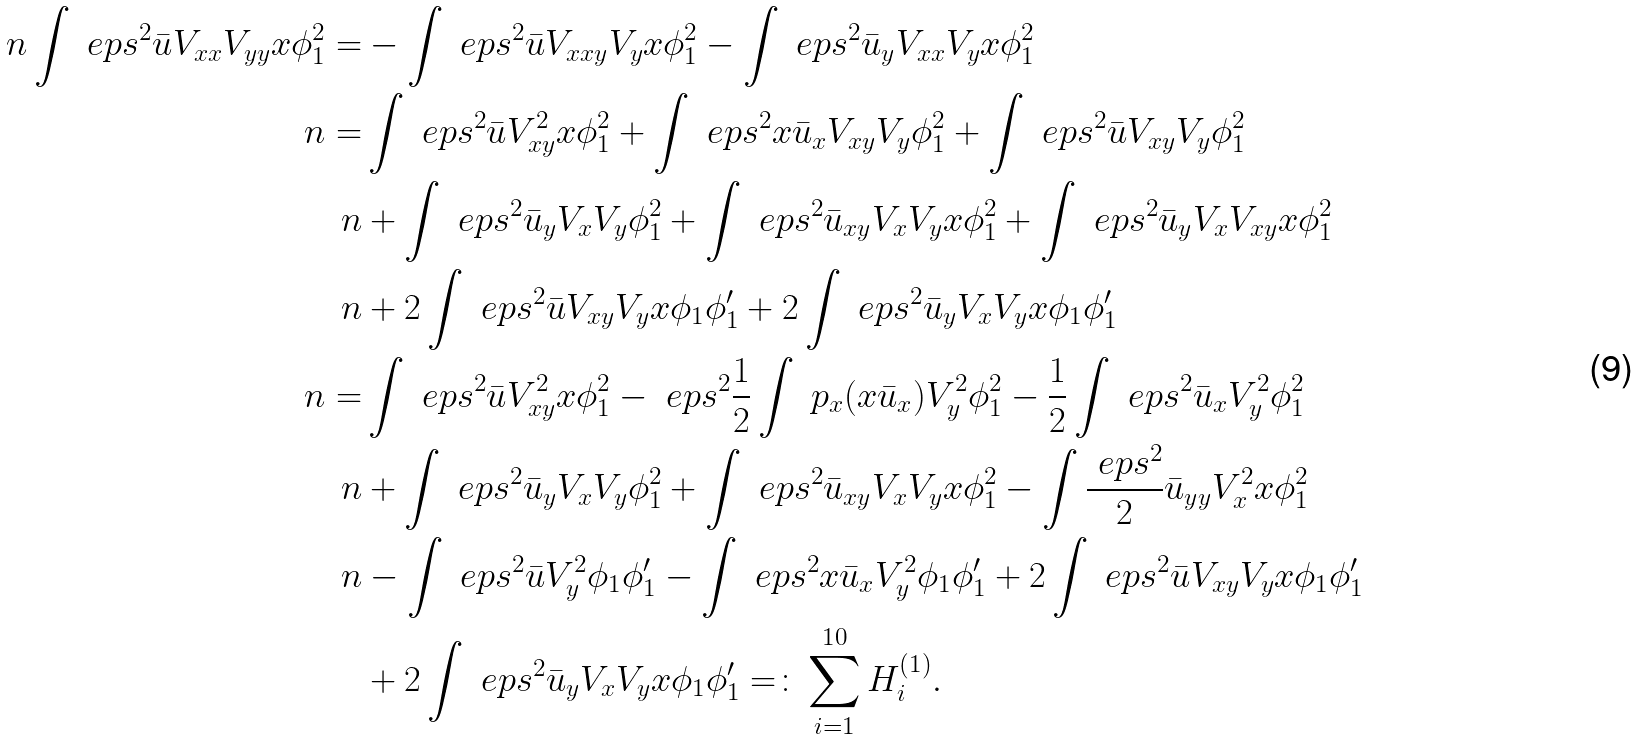<formula> <loc_0><loc_0><loc_500><loc_500>\ n \int \ e p s ^ { 2 } \bar { u } V _ { x x } V _ { y y } x \phi _ { 1 } ^ { 2 } = & - \int \ e p s ^ { 2 } \bar { u } V _ { x x y } V _ { y } x \phi _ { 1 } ^ { 2 } - \int \ e p s ^ { 2 } \bar { u } _ { y } V _ { x x } V _ { y } x \phi _ { 1 } ^ { 2 } \\ \ n = & \int \ e p s ^ { 2 } \bar { u } V _ { x y } ^ { 2 } x \phi _ { 1 } ^ { 2 } + \int \ e p s ^ { 2 } x \bar { u } _ { x } V _ { x y } V _ { y } \phi _ { 1 } ^ { 2 } + \int \ e p s ^ { 2 } \bar { u } V _ { x y } V _ { y } \phi _ { 1 } ^ { 2 } \\ \ n & + \int \ e p s ^ { 2 } \bar { u } _ { y } V _ { x } V _ { y } \phi _ { 1 } ^ { 2 } + \int \ e p s ^ { 2 } \bar { u } _ { x y } V _ { x } V _ { y } x \phi _ { 1 } ^ { 2 } + \int \ e p s ^ { 2 } \bar { u } _ { y } V _ { x } V _ { x y } x \phi _ { 1 } ^ { 2 } \\ \ n & + 2 \int \ e p s ^ { 2 } \bar { u } V _ { x y } V _ { y } x \phi _ { 1 } \phi _ { 1 } ^ { \prime } + 2 \int \ e p s ^ { 2 } \bar { u } _ { y } V _ { x } V _ { y } x \phi _ { 1 } \phi _ { 1 } ^ { \prime } \\ \ n = & \int \ e p s ^ { 2 } \bar { u } V _ { x y } ^ { 2 } x \phi _ { 1 } ^ { 2 } - \ e p s ^ { 2 } \frac { 1 } { 2 } \int \ p _ { x } ( x \bar { u } _ { x } ) V _ { y } ^ { 2 } \phi _ { 1 } ^ { 2 } - \frac { 1 } { 2 } \int \ e p s ^ { 2 } \bar { u } _ { x } V _ { y } ^ { 2 } \phi _ { 1 } ^ { 2 } \\ \ n & + \int \ e p s ^ { 2 } \bar { u } _ { y } V _ { x } V _ { y } \phi _ { 1 } ^ { 2 } + \int \ e p s ^ { 2 } \bar { u } _ { x y } V _ { x } V _ { y } x \phi _ { 1 } ^ { 2 } - \int \frac { \ e p s ^ { 2 } } { 2 } \bar { u } _ { y y } V _ { x } ^ { 2 } x \phi _ { 1 } ^ { 2 } \\ \ n & - \int \ e p s ^ { 2 } \bar { u } V _ { y } ^ { 2 } \phi _ { 1 } \phi _ { 1 } ^ { \prime } - \int \ e p s ^ { 2 } x \bar { u } _ { x } V _ { y } ^ { 2 } \phi _ { 1 } \phi _ { 1 } ^ { \prime } + 2 \int \ e p s ^ { 2 } \bar { u } V _ { x y } V _ { y } x \phi _ { 1 } \phi _ { 1 } ^ { \prime } \\ & + 2 \int \ e p s ^ { 2 } \bar { u } _ { y } V _ { x } V _ { y } x \phi _ { 1 } \phi _ { 1 } ^ { \prime } = \colon \sum _ { i = 1 } ^ { 1 0 } H ^ { ( 1 ) } _ { i } .</formula> 